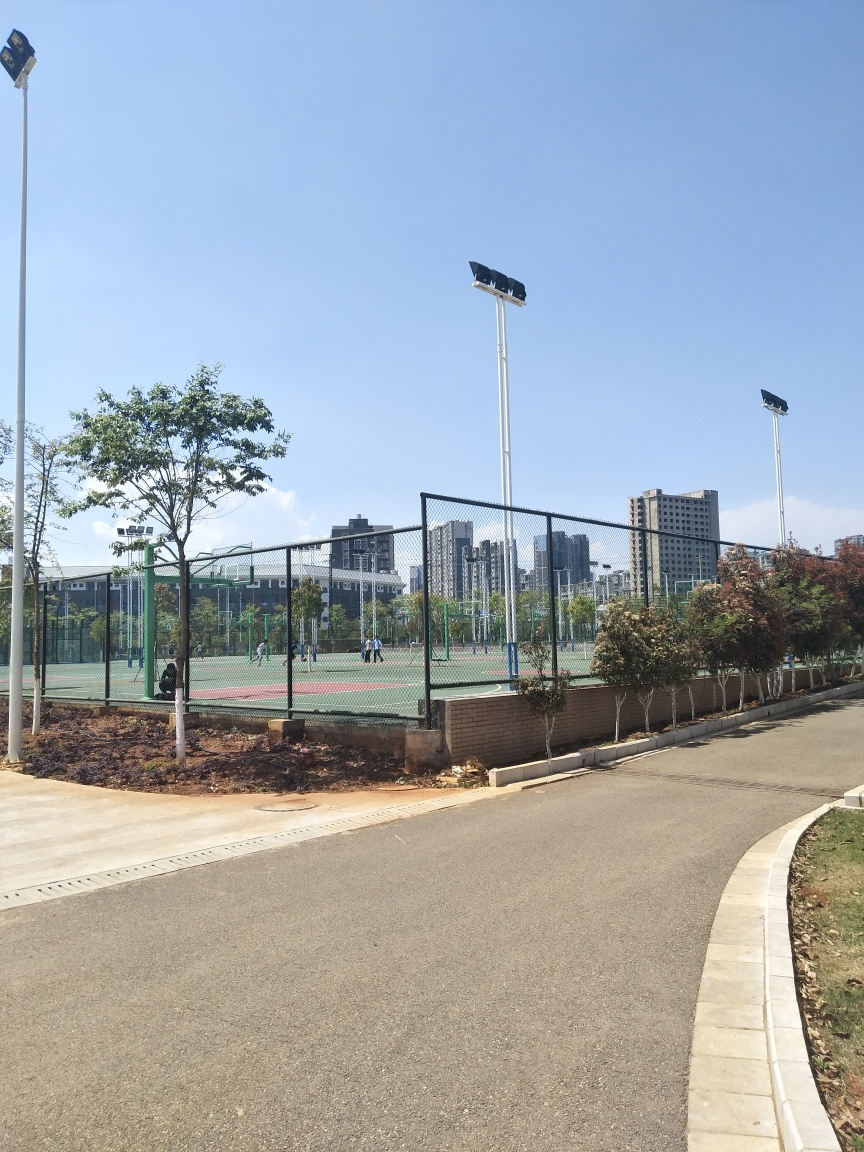What are the possible ways this public space could benefit the community? Such public spaces provide areas for physical exercise, community gatherings, and relaxation. They enhance community well-being and encourage a healthy lifestyle. 